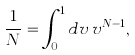<formula> <loc_0><loc_0><loc_500><loc_500>\frac { 1 } { N } = \int _ { 0 } ^ { 1 } d v \, v ^ { N - 1 } ,</formula> 